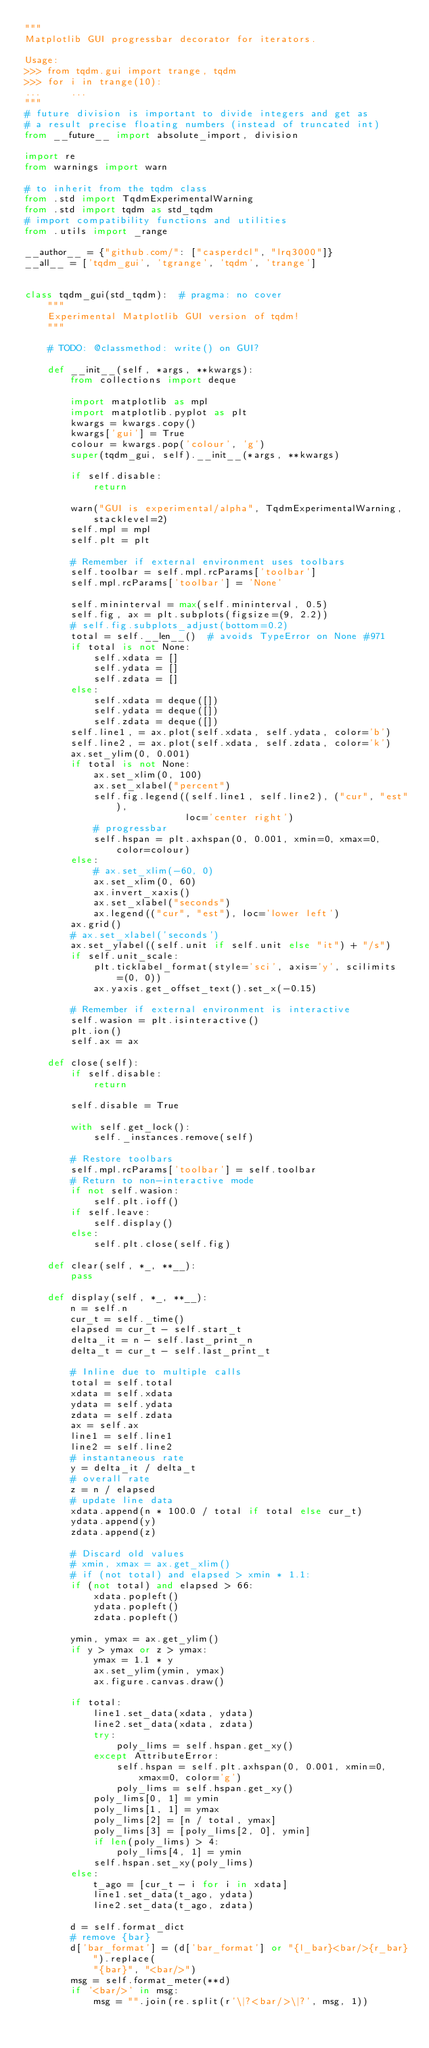Convert code to text. <code><loc_0><loc_0><loc_500><loc_500><_Python_>"""
Matplotlib GUI progressbar decorator for iterators.

Usage:
>>> from tqdm.gui import trange, tqdm
>>> for i in trange(10):
...     ...
"""
# future division is important to divide integers and get as
# a result precise floating numbers (instead of truncated int)
from __future__ import absolute_import, division

import re
from warnings import warn

# to inherit from the tqdm class
from .std import TqdmExperimentalWarning
from .std import tqdm as std_tqdm
# import compatibility functions and utilities
from .utils import _range

__author__ = {"github.com/": ["casperdcl", "lrq3000"]}
__all__ = ['tqdm_gui', 'tgrange', 'tqdm', 'trange']


class tqdm_gui(std_tqdm):  # pragma: no cover
    """
    Experimental Matplotlib GUI version of tqdm!
    """

    # TODO: @classmethod: write() on GUI?

    def __init__(self, *args, **kwargs):
        from collections import deque

        import matplotlib as mpl
        import matplotlib.pyplot as plt
        kwargs = kwargs.copy()
        kwargs['gui'] = True
        colour = kwargs.pop('colour', 'g')
        super(tqdm_gui, self).__init__(*args, **kwargs)

        if self.disable:
            return

        warn("GUI is experimental/alpha", TqdmExperimentalWarning, stacklevel=2)
        self.mpl = mpl
        self.plt = plt

        # Remember if external environment uses toolbars
        self.toolbar = self.mpl.rcParams['toolbar']
        self.mpl.rcParams['toolbar'] = 'None'

        self.mininterval = max(self.mininterval, 0.5)
        self.fig, ax = plt.subplots(figsize=(9, 2.2))
        # self.fig.subplots_adjust(bottom=0.2)
        total = self.__len__()  # avoids TypeError on None #971
        if total is not None:
            self.xdata = []
            self.ydata = []
            self.zdata = []
        else:
            self.xdata = deque([])
            self.ydata = deque([])
            self.zdata = deque([])
        self.line1, = ax.plot(self.xdata, self.ydata, color='b')
        self.line2, = ax.plot(self.xdata, self.zdata, color='k')
        ax.set_ylim(0, 0.001)
        if total is not None:
            ax.set_xlim(0, 100)
            ax.set_xlabel("percent")
            self.fig.legend((self.line1, self.line2), ("cur", "est"),
                            loc='center right')
            # progressbar
            self.hspan = plt.axhspan(0, 0.001, xmin=0, xmax=0, color=colour)
        else:
            # ax.set_xlim(-60, 0)
            ax.set_xlim(0, 60)
            ax.invert_xaxis()
            ax.set_xlabel("seconds")
            ax.legend(("cur", "est"), loc='lower left')
        ax.grid()
        # ax.set_xlabel('seconds')
        ax.set_ylabel((self.unit if self.unit else "it") + "/s")
        if self.unit_scale:
            plt.ticklabel_format(style='sci', axis='y', scilimits=(0, 0))
            ax.yaxis.get_offset_text().set_x(-0.15)

        # Remember if external environment is interactive
        self.wasion = plt.isinteractive()
        plt.ion()
        self.ax = ax

    def close(self):
        if self.disable:
            return

        self.disable = True

        with self.get_lock():
            self._instances.remove(self)

        # Restore toolbars
        self.mpl.rcParams['toolbar'] = self.toolbar
        # Return to non-interactive mode
        if not self.wasion:
            self.plt.ioff()
        if self.leave:
            self.display()
        else:
            self.plt.close(self.fig)

    def clear(self, *_, **__):
        pass

    def display(self, *_, **__):
        n = self.n
        cur_t = self._time()
        elapsed = cur_t - self.start_t
        delta_it = n - self.last_print_n
        delta_t = cur_t - self.last_print_t

        # Inline due to multiple calls
        total = self.total
        xdata = self.xdata
        ydata = self.ydata
        zdata = self.zdata
        ax = self.ax
        line1 = self.line1
        line2 = self.line2
        # instantaneous rate
        y = delta_it / delta_t
        # overall rate
        z = n / elapsed
        # update line data
        xdata.append(n * 100.0 / total if total else cur_t)
        ydata.append(y)
        zdata.append(z)

        # Discard old values
        # xmin, xmax = ax.get_xlim()
        # if (not total) and elapsed > xmin * 1.1:
        if (not total) and elapsed > 66:
            xdata.popleft()
            ydata.popleft()
            zdata.popleft()

        ymin, ymax = ax.get_ylim()
        if y > ymax or z > ymax:
            ymax = 1.1 * y
            ax.set_ylim(ymin, ymax)
            ax.figure.canvas.draw()

        if total:
            line1.set_data(xdata, ydata)
            line2.set_data(xdata, zdata)
            try:
                poly_lims = self.hspan.get_xy()
            except AttributeError:
                self.hspan = self.plt.axhspan(0, 0.001, xmin=0, xmax=0, color='g')
                poly_lims = self.hspan.get_xy()
            poly_lims[0, 1] = ymin
            poly_lims[1, 1] = ymax
            poly_lims[2] = [n / total, ymax]
            poly_lims[3] = [poly_lims[2, 0], ymin]
            if len(poly_lims) > 4:
                poly_lims[4, 1] = ymin
            self.hspan.set_xy(poly_lims)
        else:
            t_ago = [cur_t - i for i in xdata]
            line1.set_data(t_ago, ydata)
            line2.set_data(t_ago, zdata)

        d = self.format_dict
        # remove {bar}
        d['bar_format'] = (d['bar_format'] or "{l_bar}<bar/>{r_bar}").replace(
            "{bar}", "<bar/>")
        msg = self.format_meter(**d)
        if '<bar/>' in msg:
            msg = "".join(re.split(r'\|?<bar/>\|?', msg, 1))</code> 